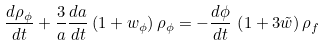Convert formula to latex. <formula><loc_0><loc_0><loc_500><loc_500>\frac { d \rho _ { \phi } } { d t } + \frac { 3 } { a } \frac { d a } { d t } \left ( 1 + w _ { \phi } \right ) \rho _ { \phi } = - \frac { d \phi } { d t } \, \left ( 1 + 3 \tilde { w } \right ) \rho _ { f } \</formula> 